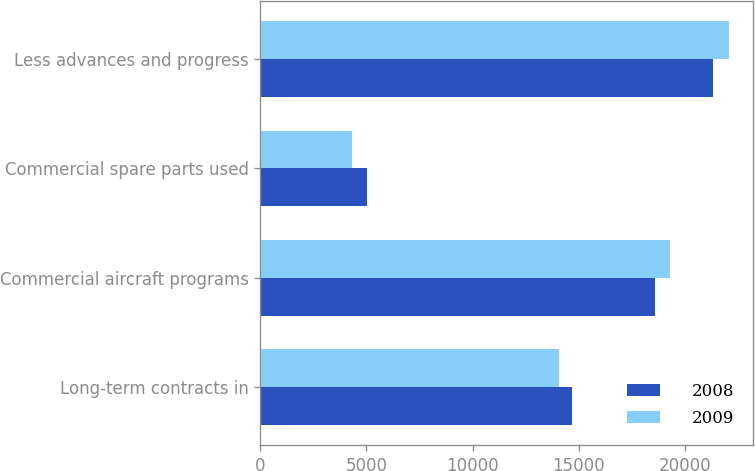Convert chart to OTSL. <chart><loc_0><loc_0><loc_500><loc_500><stacked_bar_chart><ecel><fcel>Long-term contracts in<fcel>Commercial aircraft programs<fcel>Commercial spare parts used<fcel>Less advances and progress<nl><fcel>2008<fcel>14673<fcel>18568<fcel>5004<fcel>21312<nl><fcel>2009<fcel>14051<fcel>19309<fcel>4340<fcel>22088<nl></chart> 